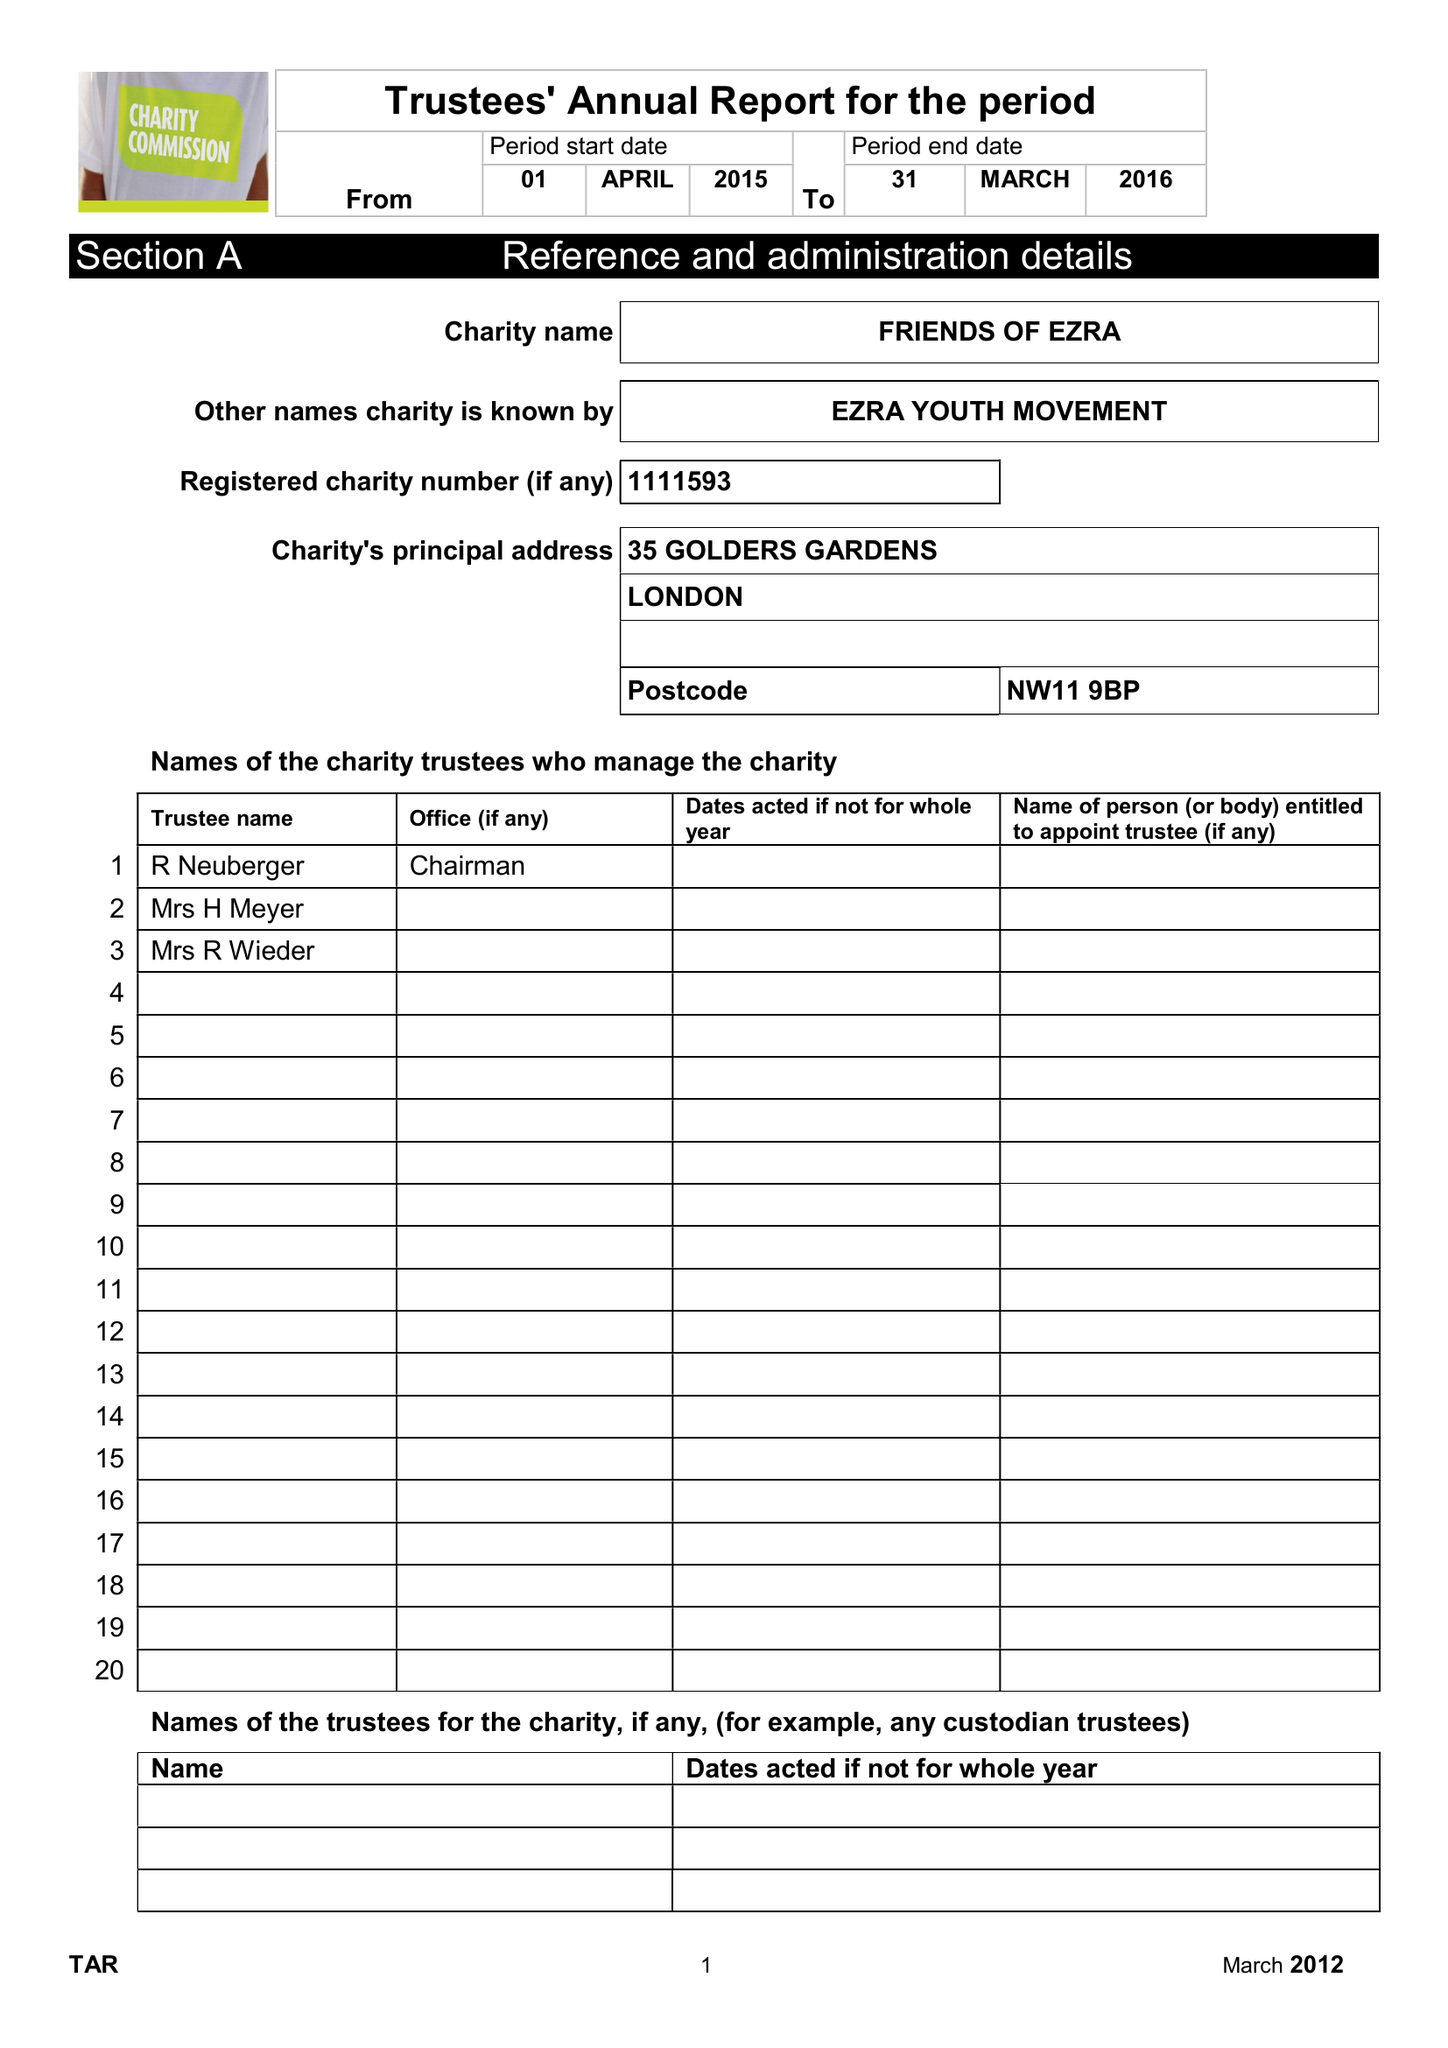What is the value for the report_date?
Answer the question using a single word or phrase. 2016-03-31 